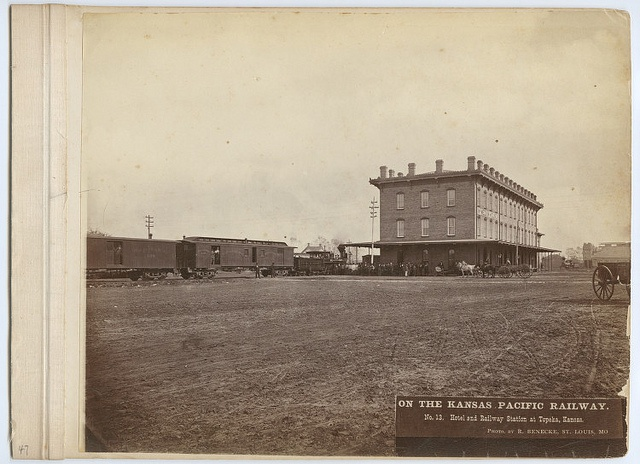Describe the objects in this image and their specific colors. I can see train in lightgray, gray, maroon, and black tones, people in lightgray, gray, and black tones, horse in lightgray, black, gray, and maroon tones, horse in lightgray, gray, and darkgray tones, and people in lightgray, black, and gray tones in this image. 